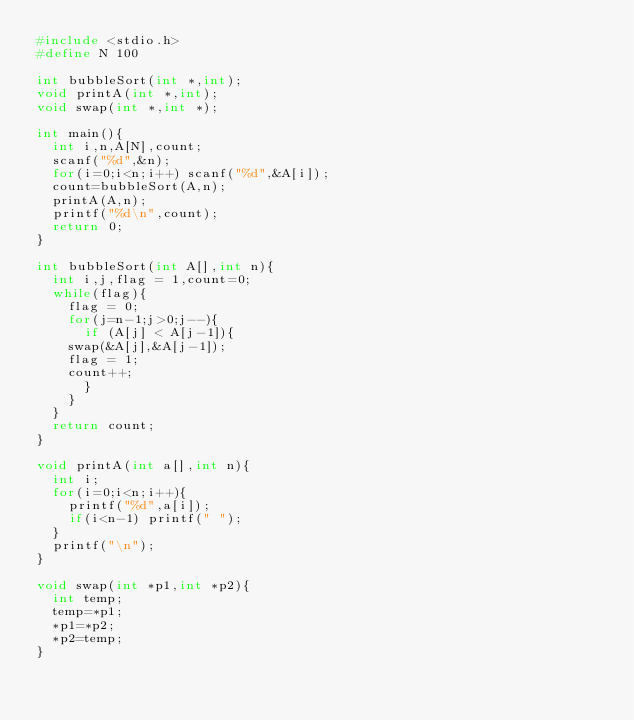<code> <loc_0><loc_0><loc_500><loc_500><_C_>#include <stdio.h>
#define N 100

int bubbleSort(int *,int);
void printA(int *,int);
void swap(int *,int *);

int main(){
  int i,n,A[N],count;
  scanf("%d",&n);
  for(i=0;i<n;i++) scanf("%d",&A[i]);
  count=bubbleSort(A,n);
  printA(A,n);
  printf("%d\n",count);
  return 0;
} 

int bubbleSort(int A[],int n){
  int i,j,flag = 1,count=0;
  while(flag){
    flag = 0;
    for(j=n-1;j>0;j--){
      if (A[j] < A[j-1]){
	swap(&A[j],&A[j-1]);
	flag = 1;
	count++;
      }
    }
  }
  return count;
}

void printA(int a[],int n){
  int i;
  for(i=0;i<n;i++){
    printf("%d",a[i]);
    if(i<n-1) printf(" ");
  }
  printf("\n");
}

void swap(int *p1,int *p2){
  int temp;
  temp=*p1;
  *p1=*p2;
  *p2=temp;
}

</code> 